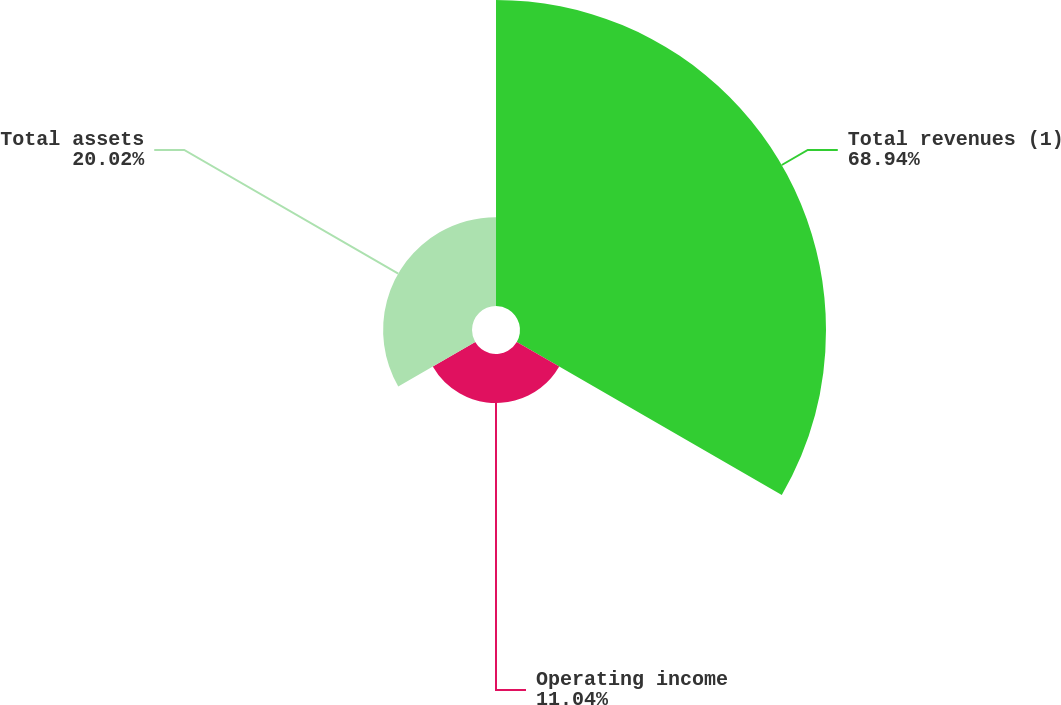Convert chart to OTSL. <chart><loc_0><loc_0><loc_500><loc_500><pie_chart><fcel>Total revenues (1)<fcel>Operating income<fcel>Total assets<nl><fcel>68.93%<fcel>11.04%<fcel>20.02%<nl></chart> 